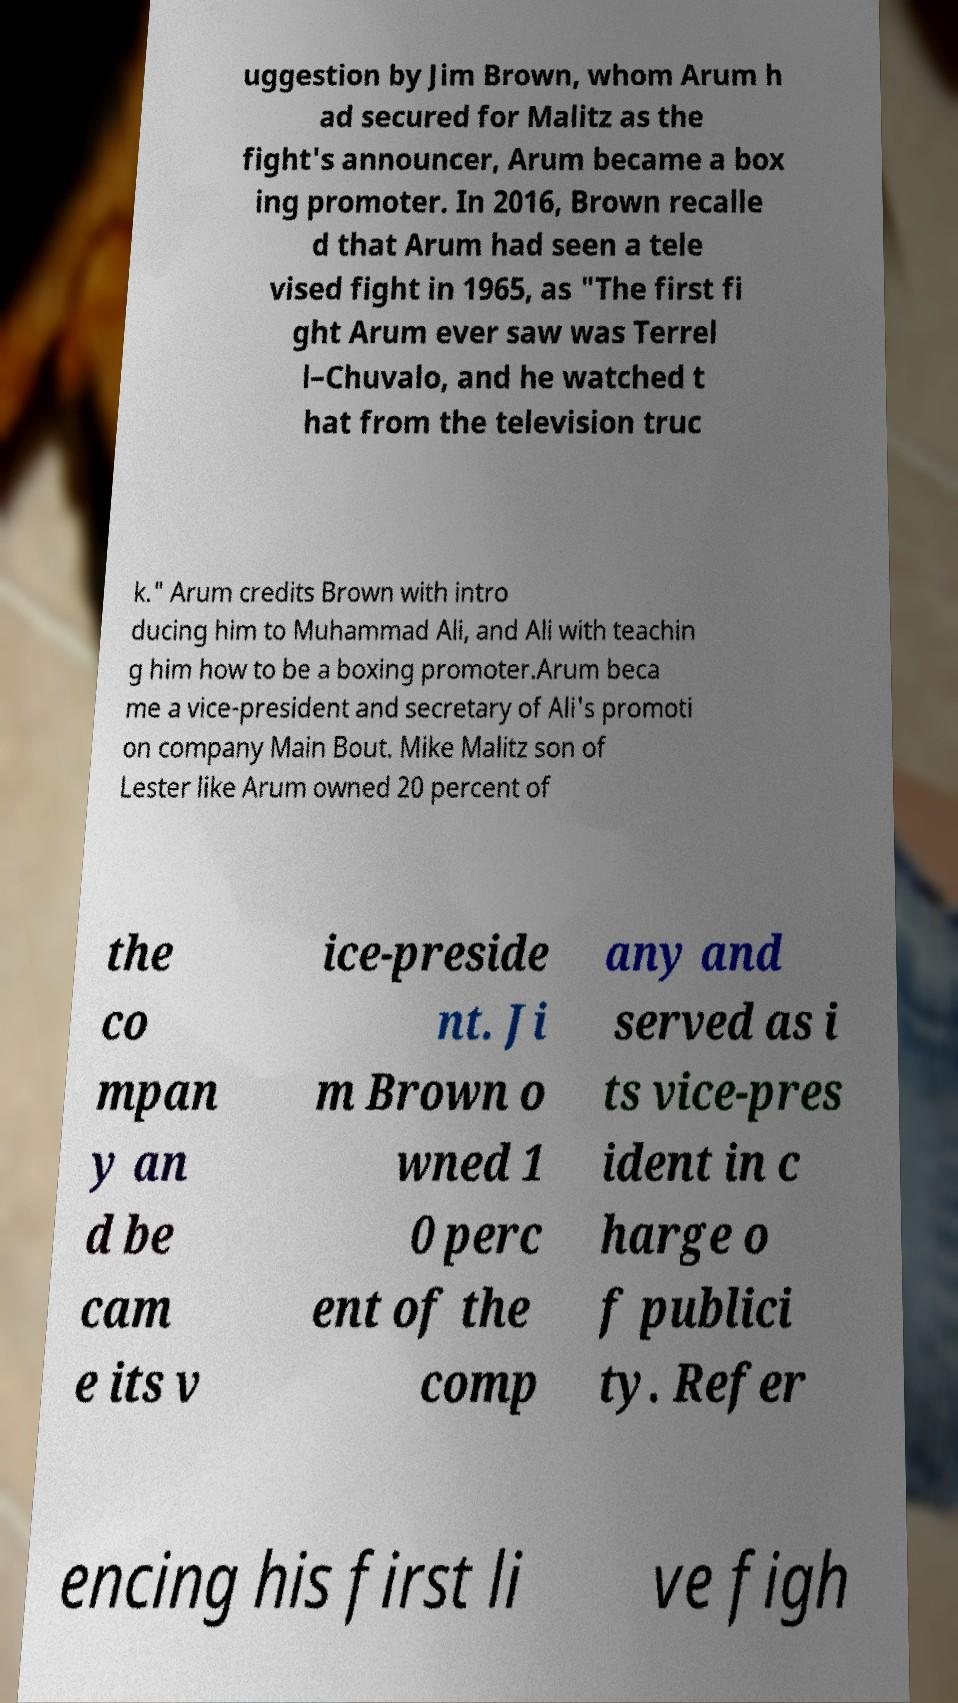Please read and relay the text visible in this image. What does it say? uggestion by Jim Brown, whom Arum h ad secured for Malitz as the fight's announcer, Arum became a box ing promoter. In 2016, Brown recalle d that Arum had seen a tele vised fight in 1965, as "The first fi ght Arum ever saw was Terrel l–Chuvalo, and he watched t hat from the television truc k." Arum credits Brown with intro ducing him to Muhammad Ali, and Ali with teachin g him how to be a boxing promoter.Arum beca me a vice-president and secretary of Ali's promoti on company Main Bout. Mike Malitz son of Lester like Arum owned 20 percent of the co mpan y an d be cam e its v ice-preside nt. Ji m Brown o wned 1 0 perc ent of the comp any and served as i ts vice-pres ident in c harge o f publici ty. Refer encing his first li ve figh 